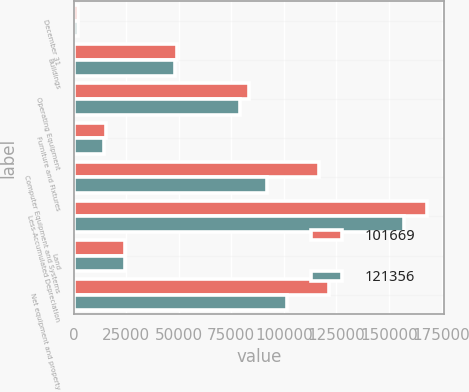<chart> <loc_0><loc_0><loc_500><loc_500><stacked_bar_chart><ecel><fcel>December 31<fcel>Buildings<fcel>Operating Equipment<fcel>Furniture and Fixtures<fcel>Computer Equipment and Systems<fcel>Less-Accumulated Depreciation<fcel>Land<fcel>Net equipment and property<nl><fcel>101669<fcel>2015<fcel>49282<fcel>83591<fcel>15168<fcel>116823<fcel>167998<fcel>24490<fcel>121356<nl><fcel>121356<fcel>2014<fcel>48440<fcel>79235<fcel>14303<fcel>92064<fcel>156940<fcel>24567<fcel>101669<nl></chart> 